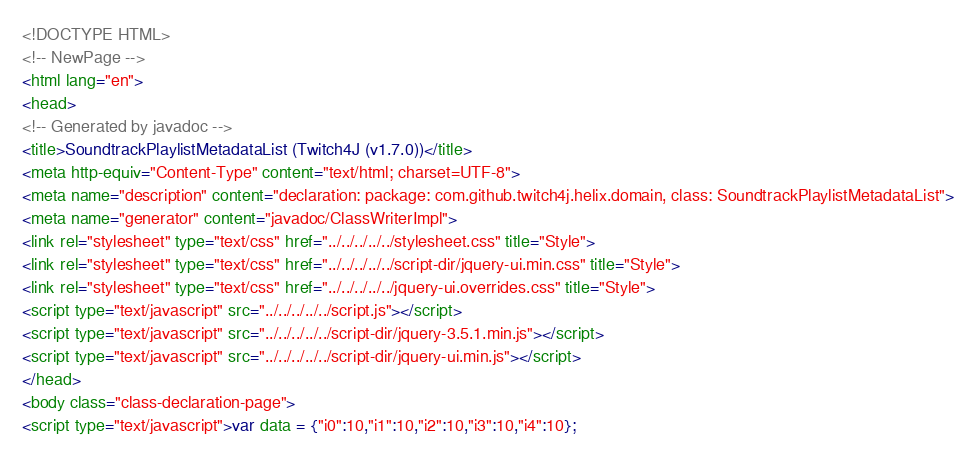<code> <loc_0><loc_0><loc_500><loc_500><_HTML_><!DOCTYPE HTML>
<!-- NewPage -->
<html lang="en">
<head>
<!-- Generated by javadoc -->
<title>SoundtrackPlaylistMetadataList (Twitch4J (v1.7.0))</title>
<meta http-equiv="Content-Type" content="text/html; charset=UTF-8">
<meta name="description" content="declaration: package: com.github.twitch4j.helix.domain, class: SoundtrackPlaylistMetadataList">
<meta name="generator" content="javadoc/ClassWriterImpl">
<link rel="stylesheet" type="text/css" href="../../../../../stylesheet.css" title="Style">
<link rel="stylesheet" type="text/css" href="../../../../../script-dir/jquery-ui.min.css" title="Style">
<link rel="stylesheet" type="text/css" href="../../../../../jquery-ui.overrides.css" title="Style">
<script type="text/javascript" src="../../../../../script.js"></script>
<script type="text/javascript" src="../../../../../script-dir/jquery-3.5.1.min.js"></script>
<script type="text/javascript" src="../../../../../script-dir/jquery-ui.min.js"></script>
</head>
<body class="class-declaration-page">
<script type="text/javascript">var data = {"i0":10,"i1":10,"i2":10,"i3":10,"i4":10};</code> 